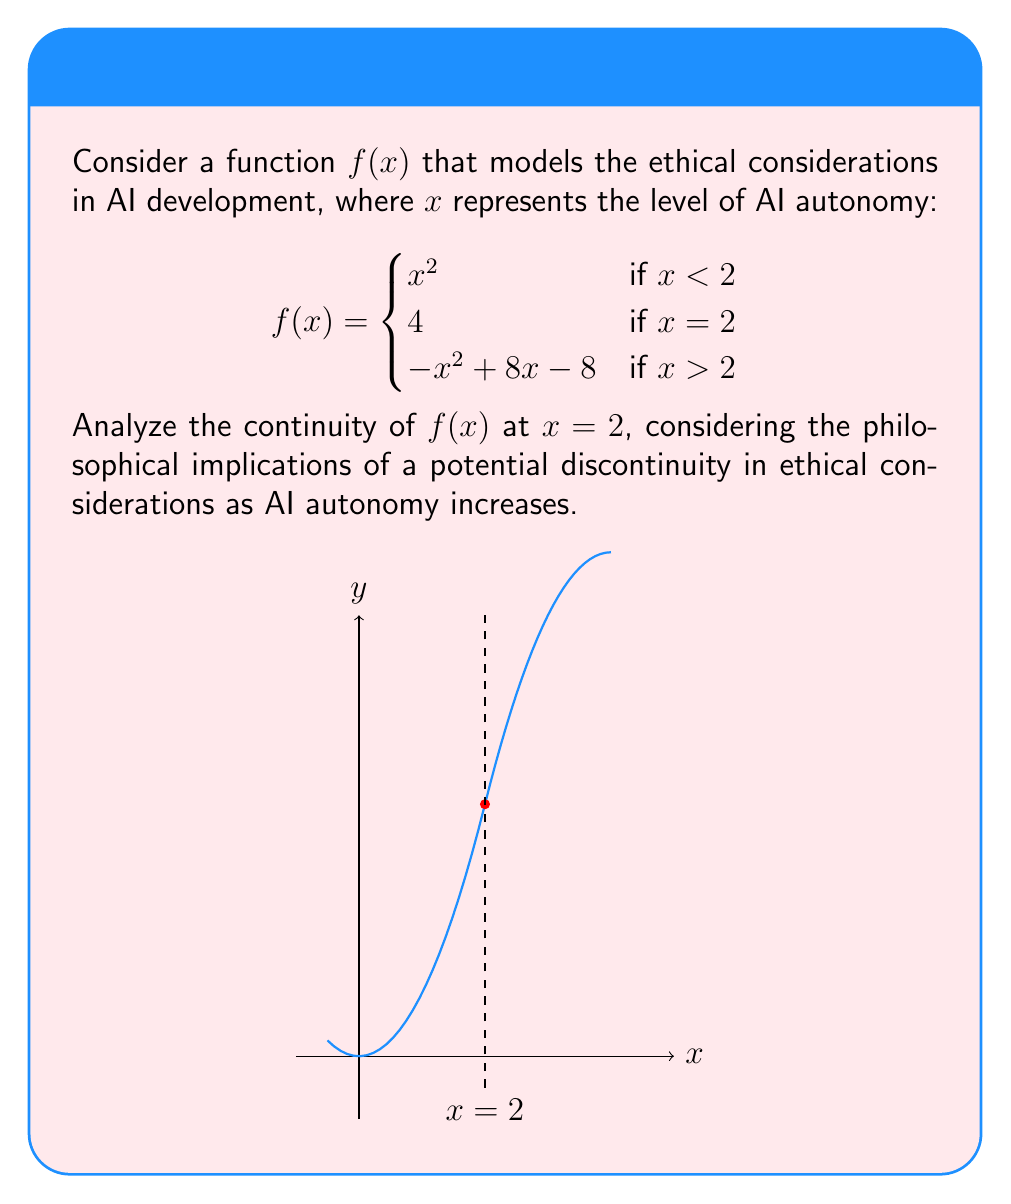Can you answer this question? To analyze the continuity of $f(x)$ at $x = 2$, we need to check three conditions:

1. $f(2)$ exists
2. $\lim_{x \to 2^-} f(x)$ exists
3. $\lim_{x \to 2^+} f(x)$ exists
4. All three values are equal

Step 1: $f(2)$ exists
From the given function definition, $f(2) = 4$

Step 2: $\lim_{x \to 2^-} f(x)$
As $x$ approaches 2 from the left, we use the first piece of the function:
$$\lim_{x \to 2^-} f(x) = \lim_{x \to 2^-} x^2 = 2^2 = 4$$

Step 3: $\lim_{x \to 2^+} f(x)$
As $x$ approaches 2 from the right, we use the third piece of the function:
$$\lim_{x \to 2^+} f(x) = \lim_{x \to 2^+} (-x^2 + 8x - 8) = -(2^2) + 8(2) - 8 = -4 + 16 - 8 = 4$$

Step 4: Comparing the values
$f(2) = 4$
$\lim_{x \to 2^-} f(x) = 4$
$\lim_{x \to 2^+} f(x) = 4$

Since all three values are equal to 4, the function $f(x)$ is continuous at $x = 2$.

Philosophical Implication: The continuity of the function at $x = 2$ suggests that there is no abrupt change in ethical considerations as AI autonomy increases through this critical point. This implies a smooth transition in ethical frameworks as AI systems become more autonomous, which is crucial for maintaining consistent ethical standards in AI development.
Answer: $f(x)$ is continuous at $x = 2$. 